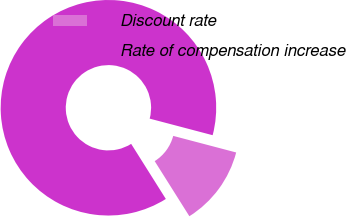<chart> <loc_0><loc_0><loc_500><loc_500><pie_chart><fcel>Discount rate<fcel>Rate of compensation increase<nl><fcel>11.96%<fcel>88.04%<nl></chart> 